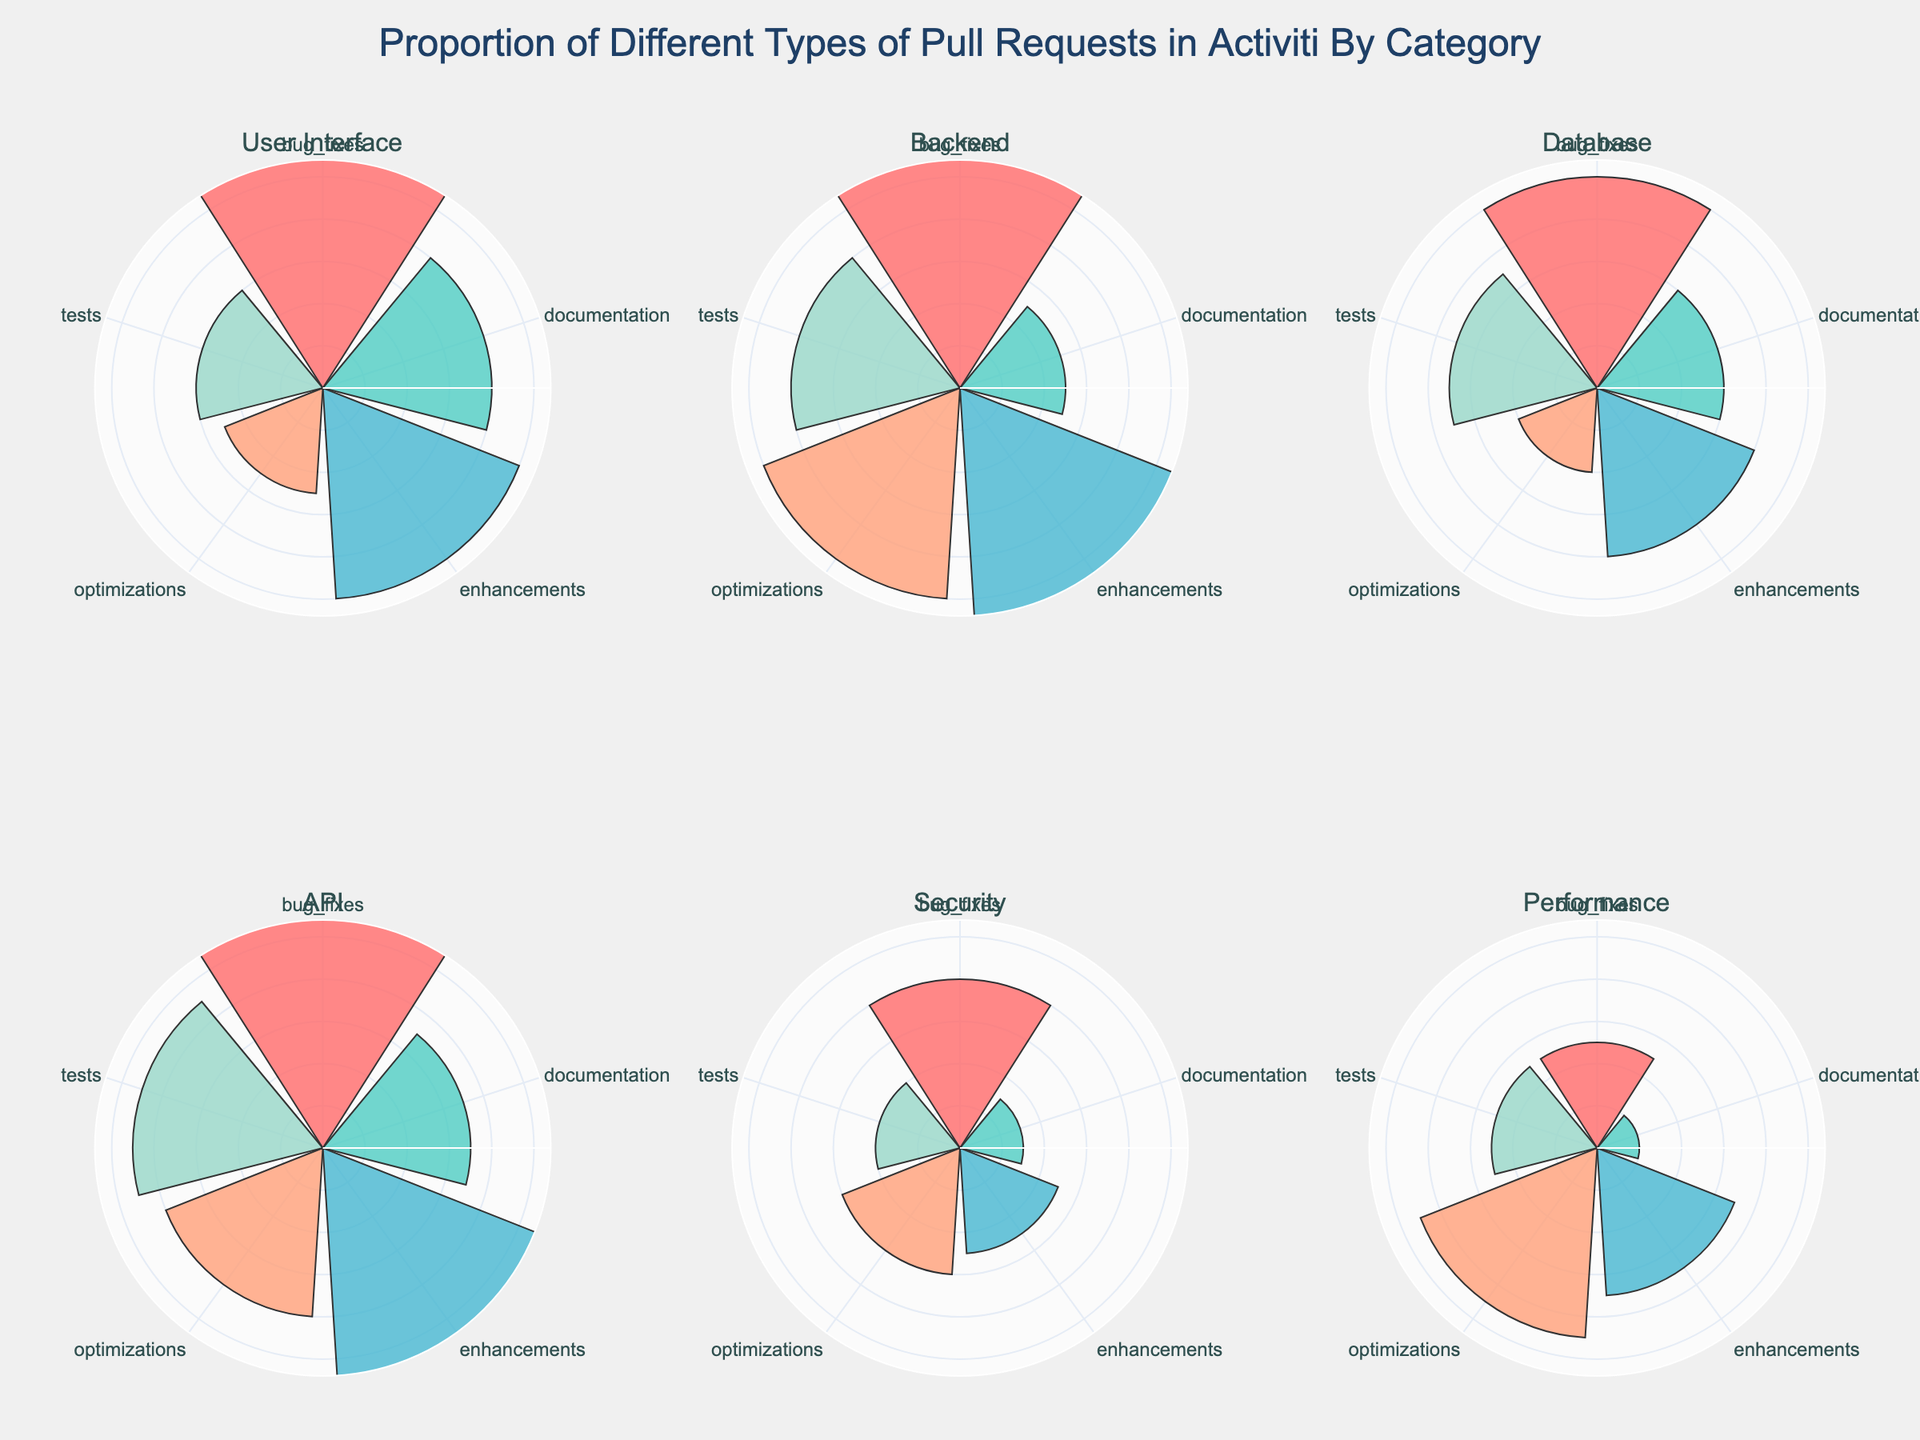What is the title of the figure? The title is prominently displayed at the top of the figure. It reads "Proportion of Different Types of Pull Requests in Activiti By Category".
Answer: Proportion of Different Types of Pull Requests in Activiti By Category How many categories of pull requests are compared in the figure? The figure consists of six subplots, each representing a different category of pull requests.
Answer: Six Which category has the highest number of bug fixes? By examining the lengths of the bars in each subplot, we see that the Backend category has the longest bar for bug fixes.
Answer: Backend In the User Interface category, which type of pull request has the smallest proportion? The smallest bar in the User Interface subplot represents optimizations.
Answer: Optimizations Which category has the most varied distribution of pull request types? To determine the variability, we should look for the subplot with bars of differing lengths. For instance, the Backend category exhibits a wide range of proportions across different types of pull requests.
Answer: Backend What is the total number of pull request types depicted in the figure? Each subplot shows 5 different types of pull requests labeled: bug fixes, documentation, enhancements, optimizations, and tests.
Answer: Five Compare the number of test pull requests between Backend and API categories. Which one has more? In the Backend category, tests are represented by an 8-unit bar, while the API category has a 9-unit bar for tests.
Answer: API What differences can be observed in the proportion of optimizations between Performance and Database categories? The Performance category’s optimizations bar is higher than that of the Database category. Specifically, Performance has a value of 9 for optimizations, whereas Database has a value of 4.
Answer: Performance Which category has the lowest number of documentation pull requests? The smallest documentation bar is in the Performance category with a value of 2.
Answer: Performance What is the average number of bug fixes across all categories? Sum up the number of bug fixes for each category (15 + 20 + 10 + 12 + 8 + 5), which equals 70. Then divide by the number of categories (6). The average is 70/6, approximately 11.67.
Answer: 11.67 